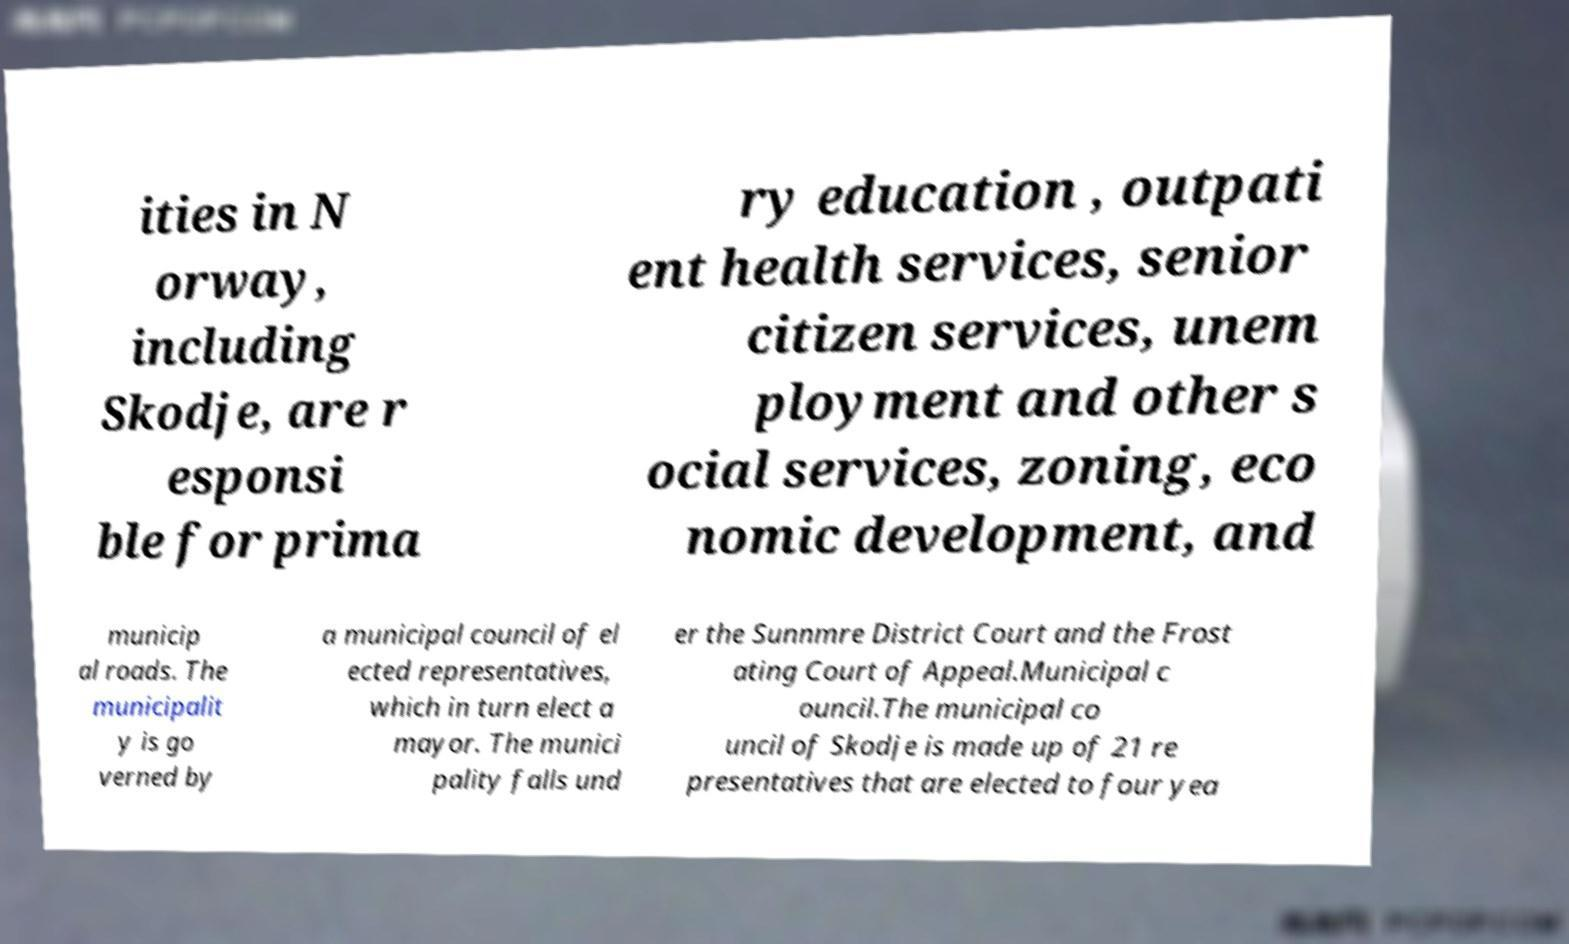There's text embedded in this image that I need extracted. Can you transcribe it verbatim? ities in N orway, including Skodje, are r esponsi ble for prima ry education , outpati ent health services, senior citizen services, unem ployment and other s ocial services, zoning, eco nomic development, and municip al roads. The municipalit y is go verned by a municipal council of el ected representatives, which in turn elect a mayor. The munici pality falls und er the Sunnmre District Court and the Frost ating Court of Appeal.Municipal c ouncil.The municipal co uncil of Skodje is made up of 21 re presentatives that are elected to four yea 